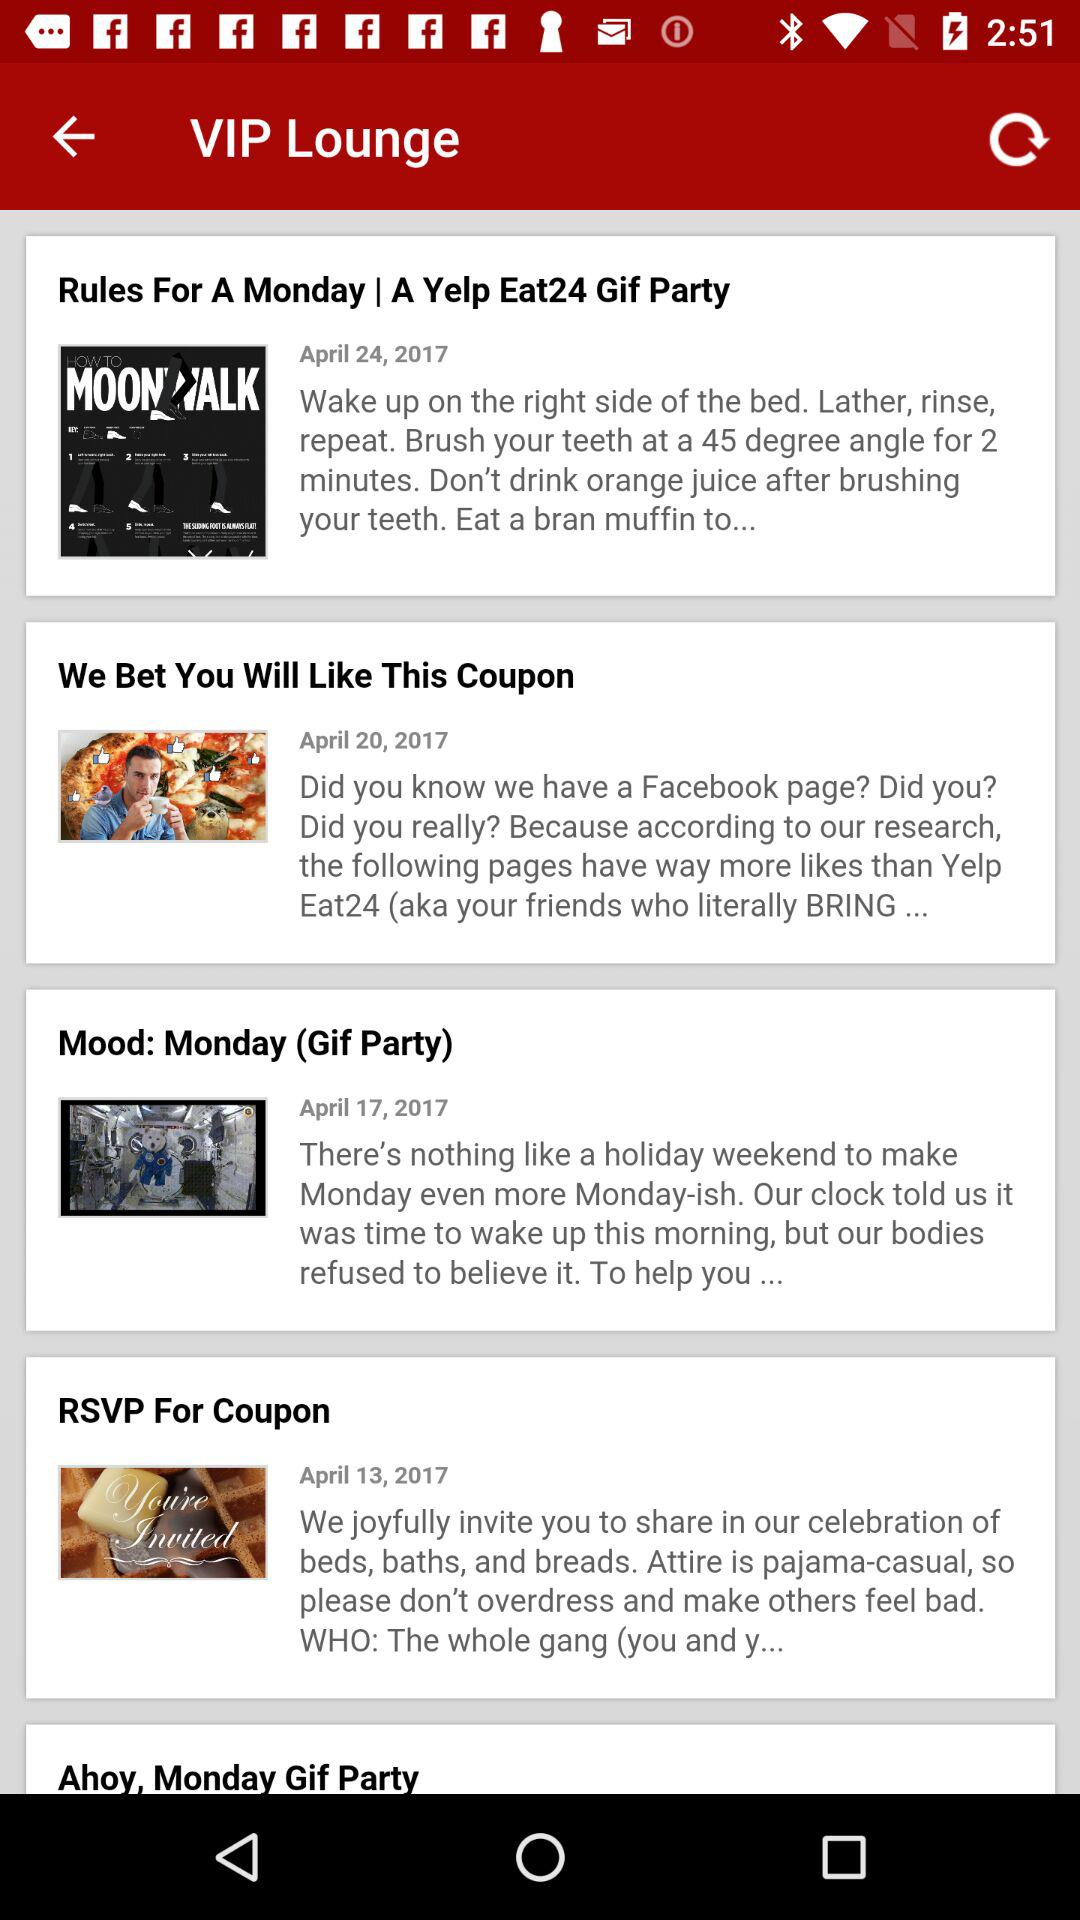On what date is "Mood: Monday (Gif Party)" updated? The date is April 17, 2017. 